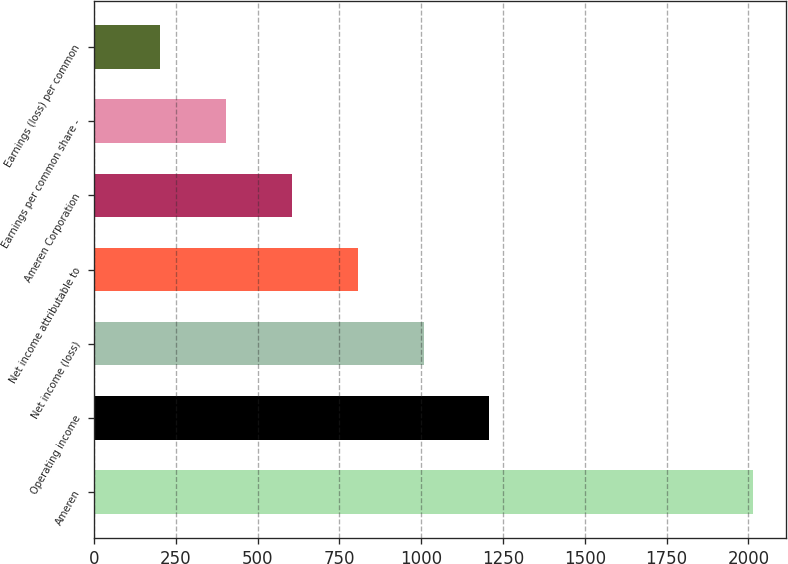Convert chart. <chart><loc_0><loc_0><loc_500><loc_500><bar_chart><fcel>Ameren<fcel>Operating income<fcel>Net income (loss)<fcel>Net income attributable to<fcel>Ameren Corporation<fcel>Earnings per common share -<fcel>Earnings (loss) per common<nl><fcel>2014<fcel>1208.56<fcel>1007.2<fcel>805.84<fcel>604.48<fcel>403.12<fcel>201.76<nl></chart> 